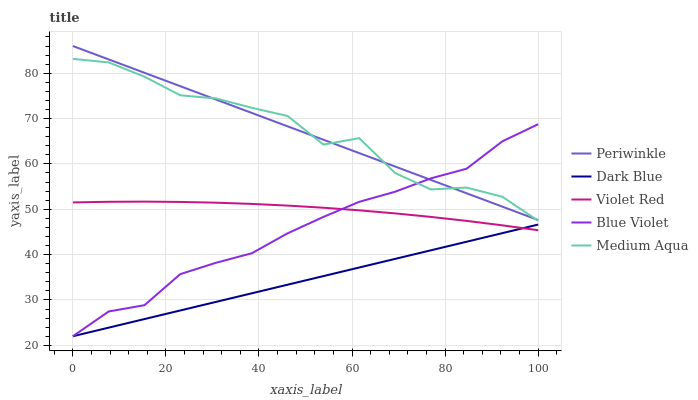Does Dark Blue have the minimum area under the curve?
Answer yes or no. Yes. Does Medium Aqua have the maximum area under the curve?
Answer yes or no. Yes. Does Violet Red have the minimum area under the curve?
Answer yes or no. No. Does Violet Red have the maximum area under the curve?
Answer yes or no. No. Is Dark Blue the smoothest?
Answer yes or no. Yes. Is Medium Aqua the roughest?
Answer yes or no. Yes. Is Violet Red the smoothest?
Answer yes or no. No. Is Violet Red the roughest?
Answer yes or no. No. Does Dark Blue have the lowest value?
Answer yes or no. Yes. Does Violet Red have the lowest value?
Answer yes or no. No. Does Periwinkle have the highest value?
Answer yes or no. Yes. Does Violet Red have the highest value?
Answer yes or no. No. Is Violet Red less than Medium Aqua?
Answer yes or no. Yes. Is Periwinkle greater than Violet Red?
Answer yes or no. Yes. Does Blue Violet intersect Periwinkle?
Answer yes or no. Yes. Is Blue Violet less than Periwinkle?
Answer yes or no. No. Is Blue Violet greater than Periwinkle?
Answer yes or no. No. Does Violet Red intersect Medium Aqua?
Answer yes or no. No. 